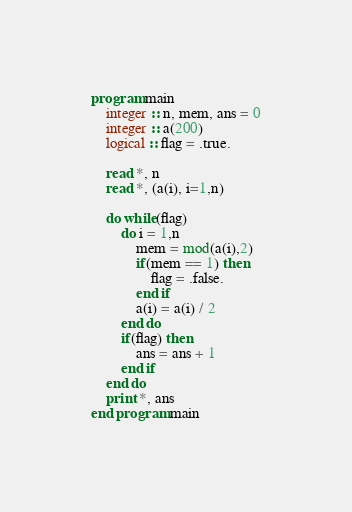<code> <loc_0><loc_0><loc_500><loc_500><_FORTRAN_>program main
    integer :: n, mem, ans = 0
    integer :: a(200)
    logical :: flag = .true.

    read *, n
    read *, (a(i), i=1,n)

    do while(flag)
        do i = 1,n
            mem = mod(a(i),2)
            if(mem == 1) then
                flag = .false.
            end if
            a(i) = a(i) / 2
        end do
        if(flag) then
            ans = ans + 1
        end if
    end do
    print *, ans
end program main</code> 